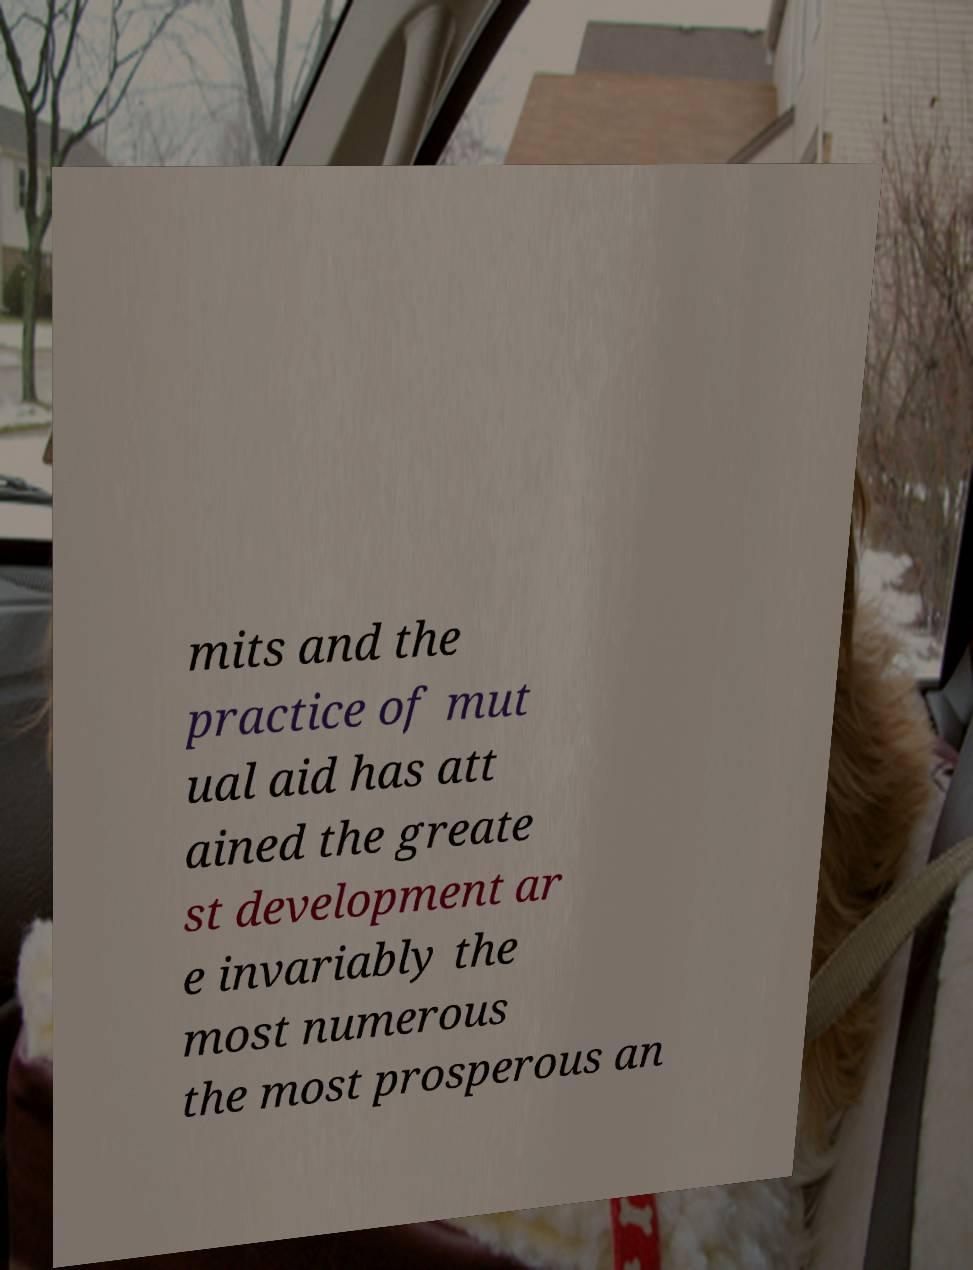I need the written content from this picture converted into text. Can you do that? mits and the practice of mut ual aid has att ained the greate st development ar e invariably the most numerous the most prosperous an 